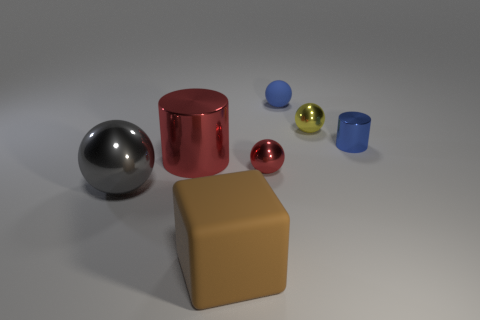Add 2 brown things. How many objects exist? 9 Subtract all cylinders. How many objects are left? 5 Add 7 small red balls. How many small red balls are left? 8 Add 7 large brown rubber objects. How many large brown rubber objects exist? 8 Subtract 0 red cubes. How many objects are left? 7 Subtract all big gray metal balls. Subtract all tiny blue shiny things. How many objects are left? 5 